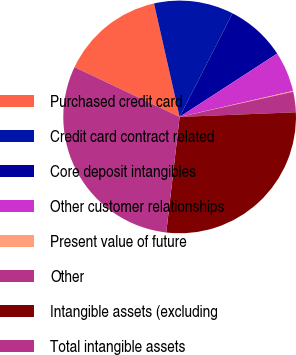Convert chart to OTSL. <chart><loc_0><loc_0><loc_500><loc_500><pie_chart><fcel>Purchased credit card<fcel>Credit card contract related<fcel>Core deposit intangibles<fcel>Other customer relationships<fcel>Present value of future<fcel>Other<fcel>Intangible assets (excluding<fcel>Total intangible assets<nl><fcel>14.42%<fcel>11.05%<fcel>8.32%<fcel>5.58%<fcel>0.11%<fcel>2.84%<fcel>27.47%<fcel>30.21%<nl></chart> 